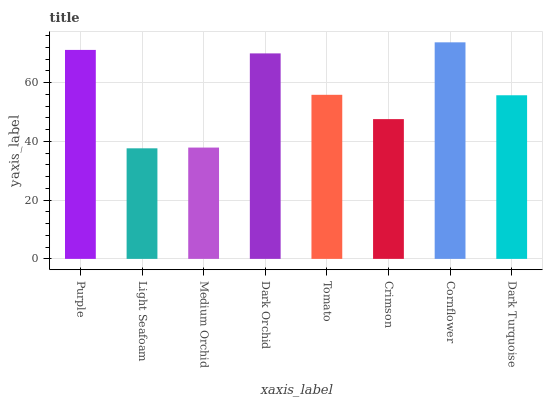Is Light Seafoam the minimum?
Answer yes or no. Yes. Is Cornflower the maximum?
Answer yes or no. Yes. Is Medium Orchid the minimum?
Answer yes or no. No. Is Medium Orchid the maximum?
Answer yes or no. No. Is Medium Orchid greater than Light Seafoam?
Answer yes or no. Yes. Is Light Seafoam less than Medium Orchid?
Answer yes or no. Yes. Is Light Seafoam greater than Medium Orchid?
Answer yes or no. No. Is Medium Orchid less than Light Seafoam?
Answer yes or no. No. Is Tomato the high median?
Answer yes or no. Yes. Is Dark Turquoise the low median?
Answer yes or no. Yes. Is Dark Orchid the high median?
Answer yes or no. No. Is Tomato the low median?
Answer yes or no. No. 